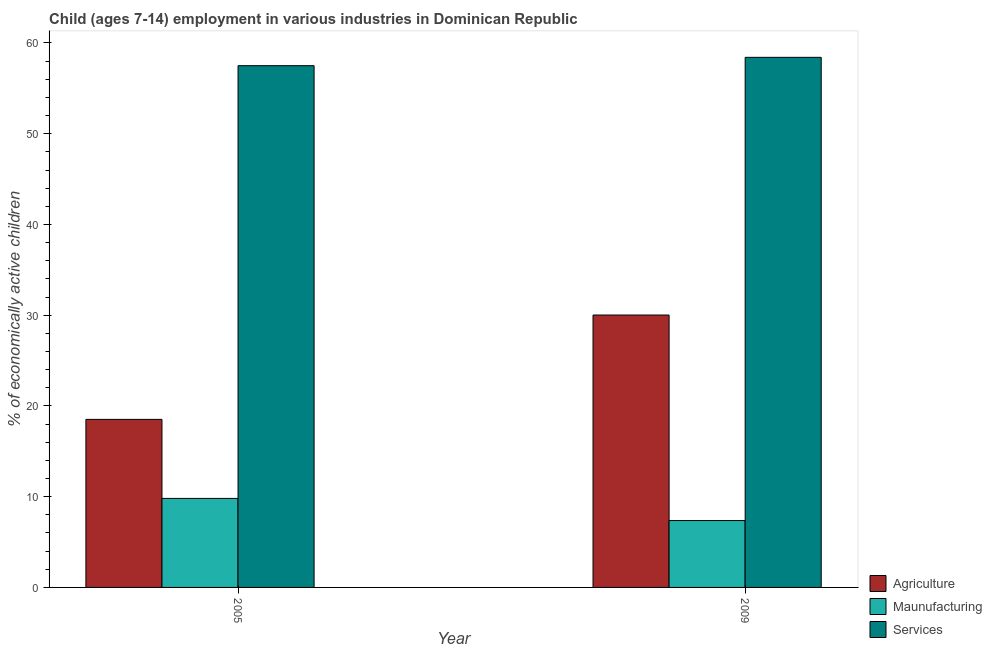How many different coloured bars are there?
Offer a terse response. 3. Are the number of bars per tick equal to the number of legend labels?
Keep it short and to the point. Yes. What is the label of the 1st group of bars from the left?
Give a very brief answer. 2005. What is the percentage of economically active children in manufacturing in 2009?
Provide a succinct answer. 7.37. Across all years, what is the maximum percentage of economically active children in manufacturing?
Offer a terse response. 9.81. Across all years, what is the minimum percentage of economically active children in agriculture?
Give a very brief answer. 18.52. What is the total percentage of economically active children in manufacturing in the graph?
Give a very brief answer. 17.18. What is the difference between the percentage of economically active children in manufacturing in 2005 and that in 2009?
Your answer should be very brief. 2.44. What is the difference between the percentage of economically active children in agriculture in 2005 and the percentage of economically active children in services in 2009?
Provide a succinct answer. -11.5. What is the average percentage of economically active children in services per year?
Your answer should be compact. 57.96. In the year 2009, what is the difference between the percentage of economically active children in agriculture and percentage of economically active children in services?
Offer a terse response. 0. In how many years, is the percentage of economically active children in manufacturing greater than 46 %?
Your answer should be compact. 0. What is the ratio of the percentage of economically active children in agriculture in 2005 to that in 2009?
Ensure brevity in your answer.  0.62. In how many years, is the percentage of economically active children in manufacturing greater than the average percentage of economically active children in manufacturing taken over all years?
Make the answer very short. 1. What does the 3rd bar from the left in 2005 represents?
Offer a terse response. Services. What does the 3rd bar from the right in 2005 represents?
Keep it short and to the point. Agriculture. Are all the bars in the graph horizontal?
Give a very brief answer. No. How many years are there in the graph?
Keep it short and to the point. 2. What is the difference between two consecutive major ticks on the Y-axis?
Provide a short and direct response. 10. Are the values on the major ticks of Y-axis written in scientific E-notation?
Give a very brief answer. No. Does the graph contain grids?
Keep it short and to the point. No. How many legend labels are there?
Give a very brief answer. 3. How are the legend labels stacked?
Your answer should be compact. Vertical. What is the title of the graph?
Keep it short and to the point. Child (ages 7-14) employment in various industries in Dominican Republic. What is the label or title of the Y-axis?
Give a very brief answer. % of economically active children. What is the % of economically active children of Agriculture in 2005?
Offer a terse response. 18.52. What is the % of economically active children of Maunufacturing in 2005?
Your answer should be very brief. 9.81. What is the % of economically active children of Services in 2005?
Your response must be concise. 57.5. What is the % of economically active children of Agriculture in 2009?
Your response must be concise. 30.02. What is the % of economically active children of Maunufacturing in 2009?
Offer a very short reply. 7.37. What is the % of economically active children in Services in 2009?
Provide a short and direct response. 58.42. Across all years, what is the maximum % of economically active children in Agriculture?
Your response must be concise. 30.02. Across all years, what is the maximum % of economically active children of Maunufacturing?
Make the answer very short. 9.81. Across all years, what is the maximum % of economically active children in Services?
Provide a short and direct response. 58.42. Across all years, what is the minimum % of economically active children of Agriculture?
Ensure brevity in your answer.  18.52. Across all years, what is the minimum % of economically active children of Maunufacturing?
Offer a very short reply. 7.37. Across all years, what is the minimum % of economically active children of Services?
Make the answer very short. 57.5. What is the total % of economically active children in Agriculture in the graph?
Make the answer very short. 48.54. What is the total % of economically active children of Maunufacturing in the graph?
Offer a terse response. 17.18. What is the total % of economically active children of Services in the graph?
Provide a short and direct response. 115.92. What is the difference between the % of economically active children of Maunufacturing in 2005 and that in 2009?
Offer a very short reply. 2.44. What is the difference between the % of economically active children of Services in 2005 and that in 2009?
Make the answer very short. -0.92. What is the difference between the % of economically active children in Agriculture in 2005 and the % of economically active children in Maunufacturing in 2009?
Offer a very short reply. 11.15. What is the difference between the % of economically active children of Agriculture in 2005 and the % of economically active children of Services in 2009?
Make the answer very short. -39.9. What is the difference between the % of economically active children of Maunufacturing in 2005 and the % of economically active children of Services in 2009?
Keep it short and to the point. -48.61. What is the average % of economically active children in Agriculture per year?
Your answer should be compact. 24.27. What is the average % of economically active children in Maunufacturing per year?
Keep it short and to the point. 8.59. What is the average % of economically active children of Services per year?
Give a very brief answer. 57.96. In the year 2005, what is the difference between the % of economically active children in Agriculture and % of economically active children in Maunufacturing?
Keep it short and to the point. 8.71. In the year 2005, what is the difference between the % of economically active children in Agriculture and % of economically active children in Services?
Your answer should be compact. -38.98. In the year 2005, what is the difference between the % of economically active children in Maunufacturing and % of economically active children in Services?
Provide a short and direct response. -47.69. In the year 2009, what is the difference between the % of economically active children in Agriculture and % of economically active children in Maunufacturing?
Ensure brevity in your answer.  22.65. In the year 2009, what is the difference between the % of economically active children in Agriculture and % of economically active children in Services?
Keep it short and to the point. -28.4. In the year 2009, what is the difference between the % of economically active children in Maunufacturing and % of economically active children in Services?
Provide a succinct answer. -51.05. What is the ratio of the % of economically active children of Agriculture in 2005 to that in 2009?
Ensure brevity in your answer.  0.62. What is the ratio of the % of economically active children in Maunufacturing in 2005 to that in 2009?
Offer a terse response. 1.33. What is the ratio of the % of economically active children in Services in 2005 to that in 2009?
Offer a very short reply. 0.98. What is the difference between the highest and the second highest % of economically active children of Maunufacturing?
Make the answer very short. 2.44. What is the difference between the highest and the lowest % of economically active children of Maunufacturing?
Offer a very short reply. 2.44. 